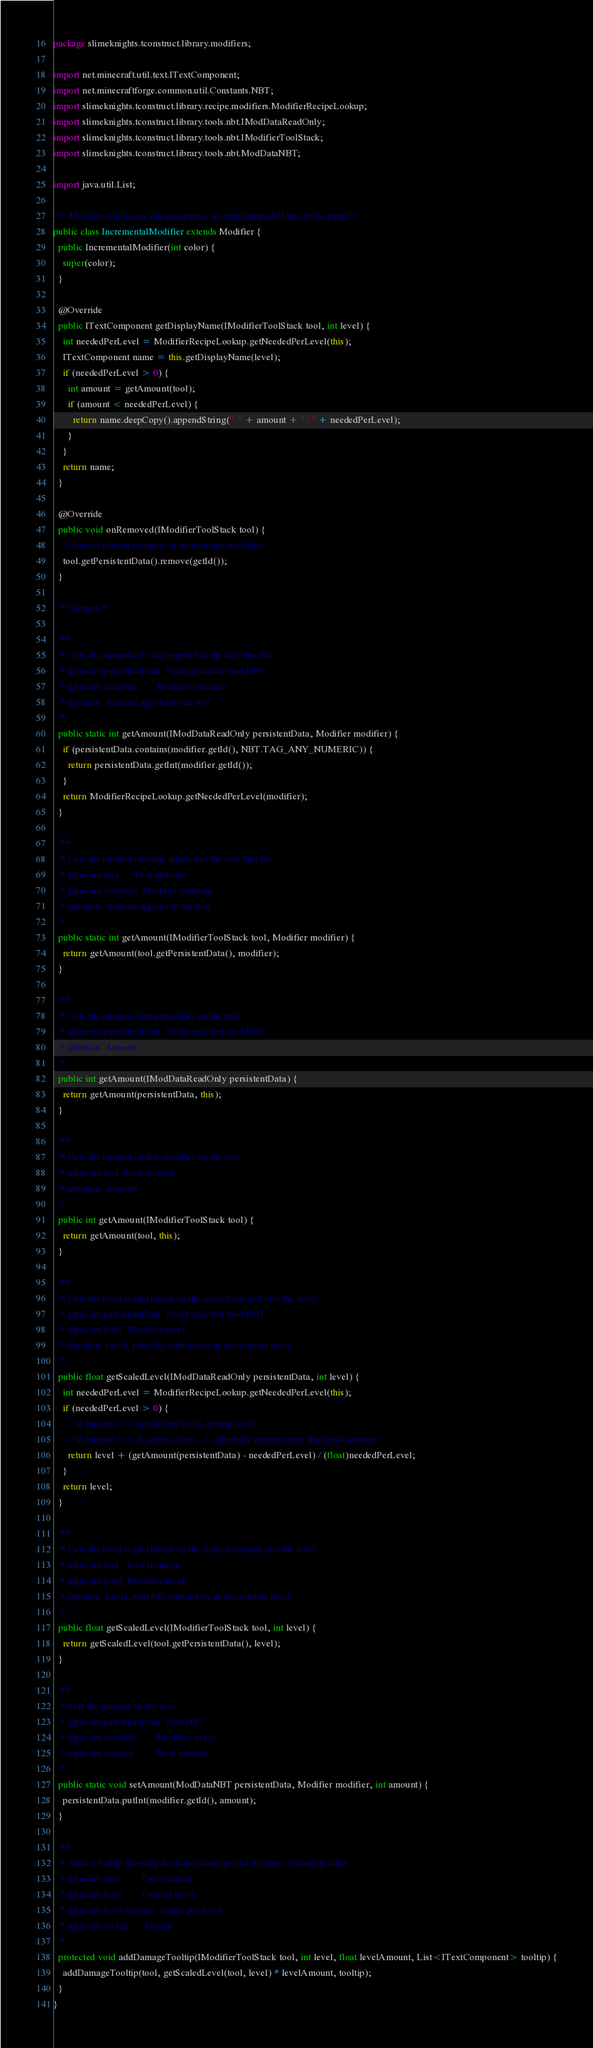<code> <loc_0><loc_0><loc_500><loc_500><_Java_>package slimeknights.tconstruct.library.modifiers;

import net.minecraft.util.text.ITextComponent;
import net.minecraftforge.common.util.Constants.NBT;
import slimeknights.tconstruct.library.recipe.modifiers.ModifierRecipeLookup;
import slimeknights.tconstruct.library.tools.nbt.IModDataReadOnly;
import slimeknights.tconstruct.library.tools.nbt.IModifierToolStack;
import slimeknights.tconstruct.library.tools.nbt.ModDataNBT;

import java.util.List;

/** Modifier which can take just part of an input instead of the whole input */
public class IncrementalModifier extends Modifier {
  public IncrementalModifier(int color) {
    super(color);
  }

  @Override
  public ITextComponent getDisplayName(IModifierToolStack tool, int level) {
    int neededPerLevel = ModifierRecipeLookup.getNeededPerLevel(this);
    ITextComponent name = this.getDisplayName(level);
    if (neededPerLevel > 0) {
      int amount = getAmount(tool);
      if (amount < neededPerLevel) {
        return name.deepCopy().appendString(": " + amount + " / " + neededPerLevel);
      }
    }
    return name;
  }

  @Override
  public void onRemoved(IModifierToolStack tool) {
    // remove current progress in incremental modifiers
    tool.getPersistentData().remove(getId());
  }

  /* Helpers */

  /**
   * Gets the amount of value applied to the tool thus far
   * @param persistentData  Tool persistent mod NBT
   * @param modifier        Modifier instance
   * @return  Amount applied to the tool
   */
  public static int getAmount(IModDataReadOnly persistentData, Modifier modifier) {
    if (persistentData.contains(modifier.getId(), NBT.TAG_ANY_NUMERIC)) {
      return persistentData.getInt(modifier.getId());
    }
    return ModifierRecipeLookup.getNeededPerLevel(modifier);
  }

  /**
   * Gets the amount of value applied to the tool thus far
   * @param tool      Tool instance
   * @param modifier  Modifier instance
   * @return  Amount applied to the tool
   */
  public static int getAmount(IModifierToolStack tool, Modifier modifier) {
    return getAmount(tool.getPersistentData(), modifier);
  }

  /**
   * Gets the amount of this modifier on the tool
   * @param persistentData  Tool persistent mod NBT
   * @return  Amount
   */
  public int getAmount(IModDataReadOnly persistentData) {
    return getAmount(persistentData, this);
  }

  /**
   * Gets the amount of this modifier on the tool
   * @param tool  Tool amount
   * @return  Amount
   */
  public int getAmount(IModifierToolStack tool) {
    return getAmount(tool, this);
  }

  /**
   * Gets the level scaled based on the current amount into the level
   * @param persistentData  Tool persistent mod NBT
   * @param level  Modifier level
   * @return  Level, possibly reduced by an incomplete level
   */
  public float getScaledLevel(IModDataReadOnly persistentData, int level) {
    int neededPerLevel = ModifierRecipeLookup.getNeededPerLevel(this);
    if (neededPerLevel > 0) {
      // if amount == needed per level, returns level
      // if amount == 0, returns level - 1, otherwise returns some fractional amount
      return level + (getAmount(persistentData) - neededPerLevel) / (float)neededPerLevel;
    }
    return level;
  }

  /**
   * Gets the level scaled based on the current amount into the level
   * @param tool   Tool instance
   * @param level  Modifier level
   * @return  Level, possibly reduced by an incomplete level
   */
  public float getScaledLevel(IModifierToolStack tool, int level) {
    return getScaledLevel(tool.getPersistentData(), level);
  }

  /**
   * Sets the amount on the tool
   * @param persistentData  Tool NBT
   * @param modifier        Modifier to set
   * @param amount          New amount
   */
  public static void setAmount(ModDataNBT persistentData, Modifier modifier, int amount) {
    persistentData.putInt(modifier.getId(), amount);
  }

  /**
   * Adds a tooltip showing the bonus damage and the type of damage dded
   * @param tool         Tool instance
   * @param level        Current level
   * @param levelAmount  Bonus per level
   * @param tooltip      Tooltip
   */
  protected void addDamageTooltip(IModifierToolStack tool, int level, float levelAmount, List<ITextComponent> tooltip) {
    addDamageTooltip(tool, getScaledLevel(tool, level) * levelAmount, tooltip);
  }
}
</code> 